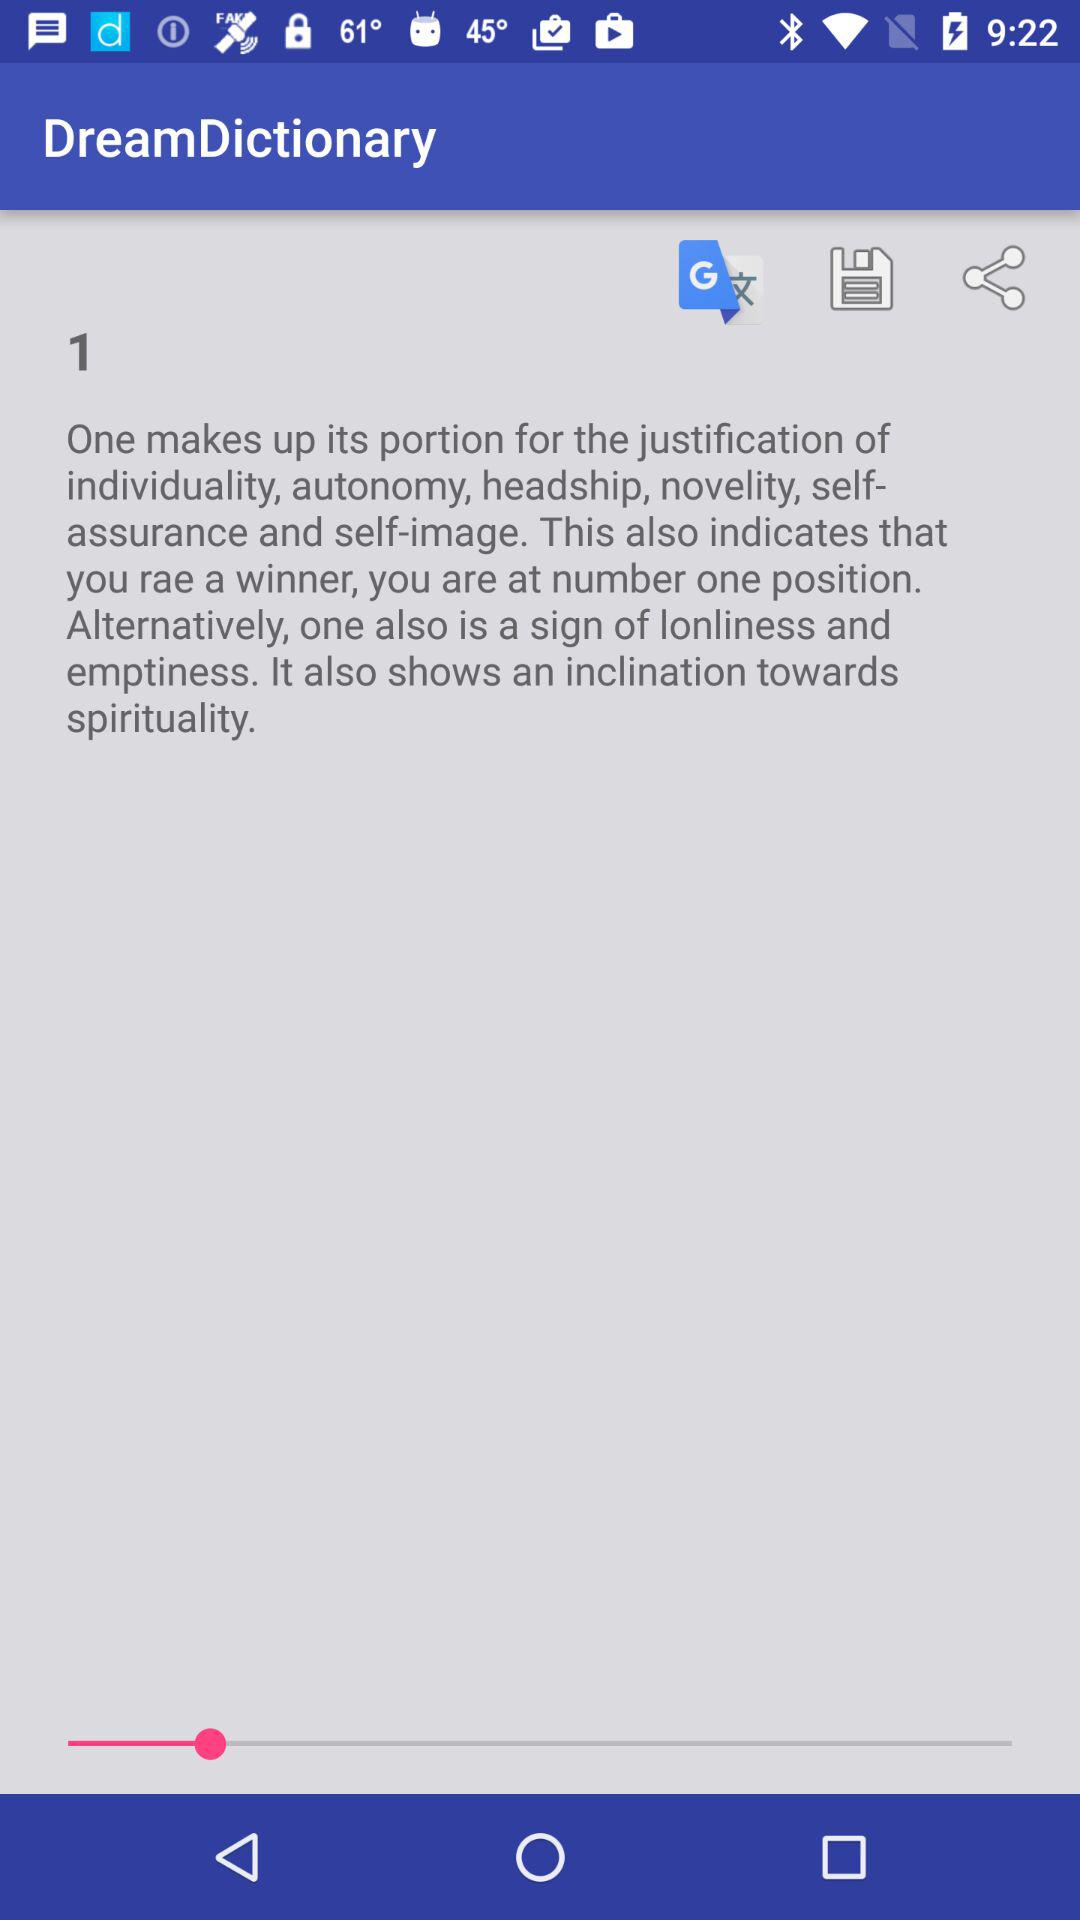Which applications are available for sharing?
When the provided information is insufficient, respond with <no answer>. <no answer> 